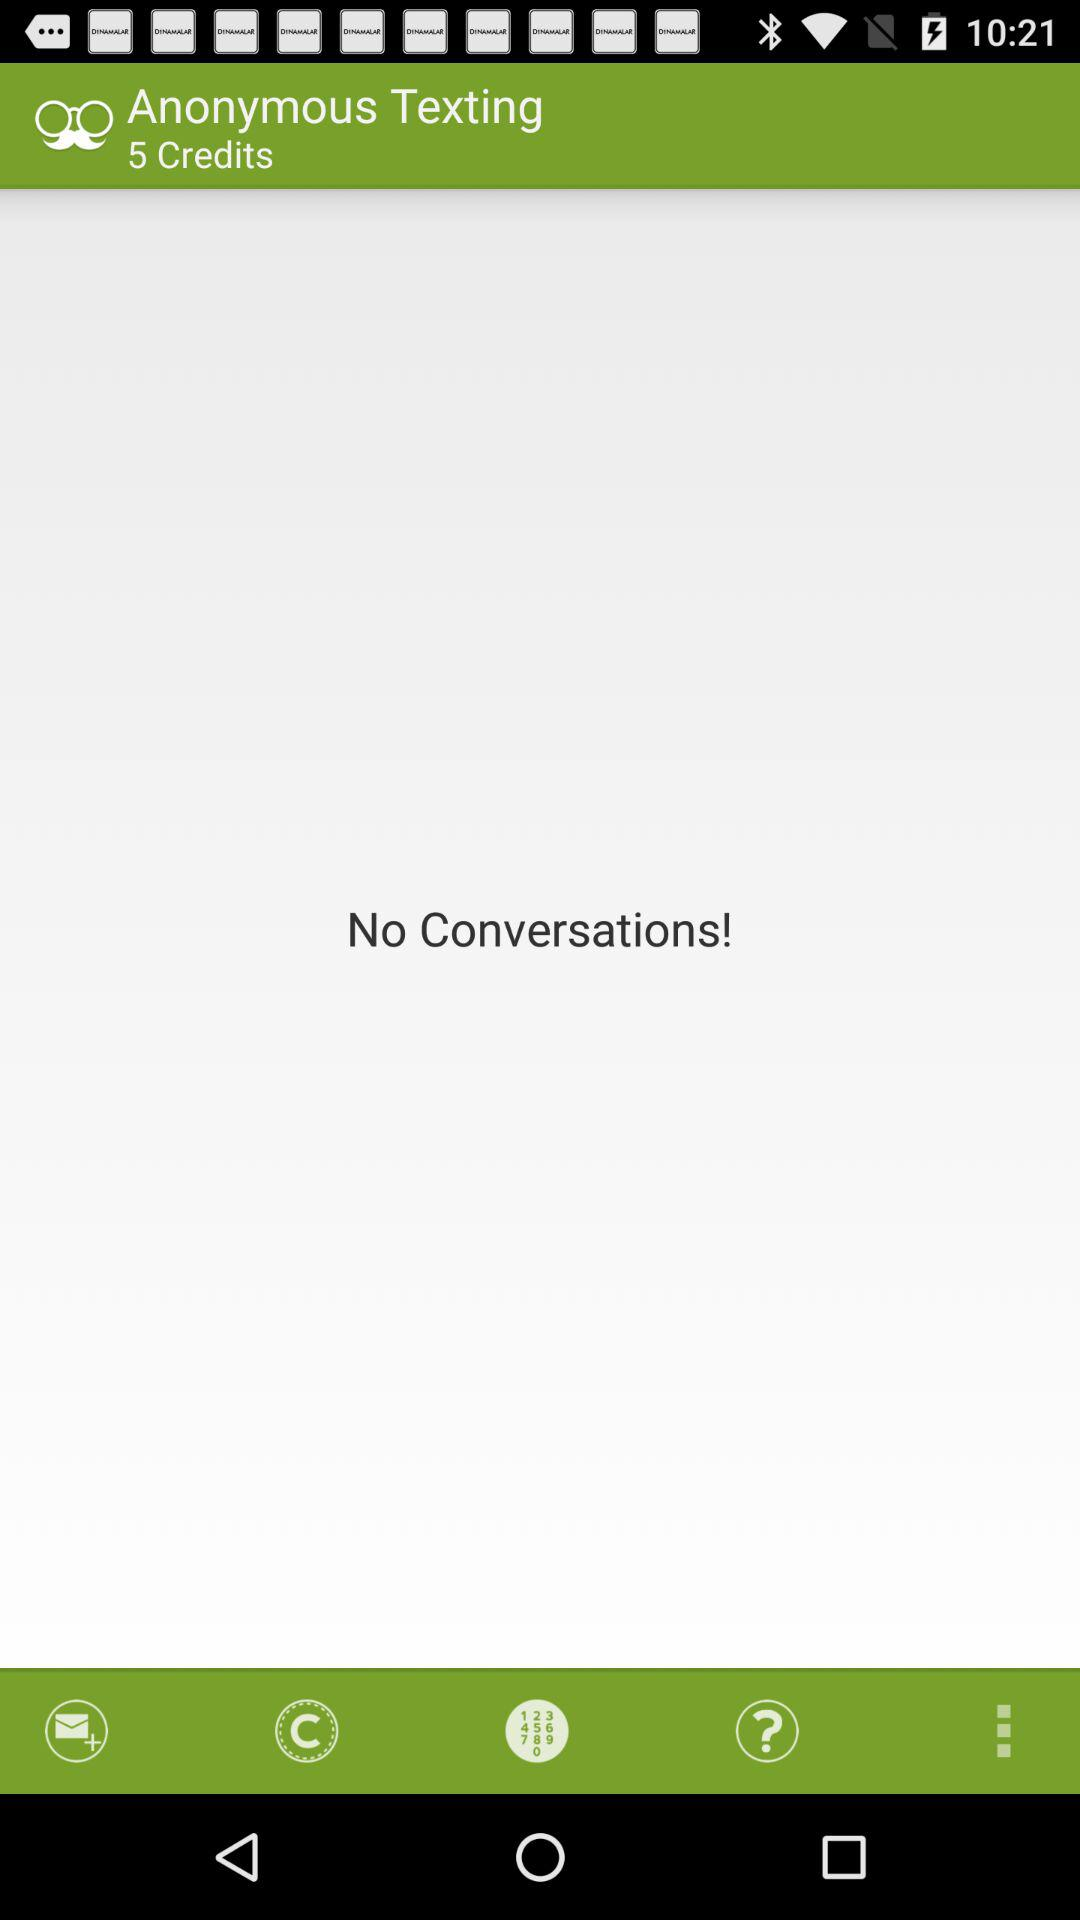How many credits do I have?
Answer the question using a single word or phrase. 5 